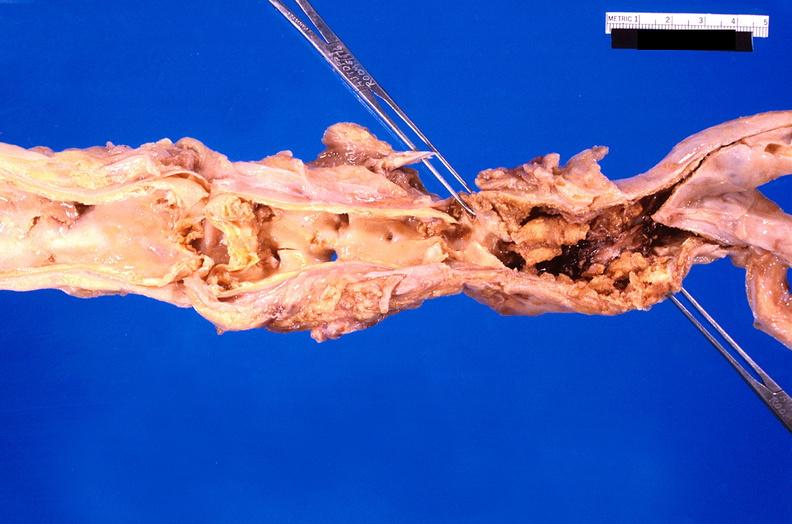what is present?
Answer the question using a single word or phrase. Cardiovascular 